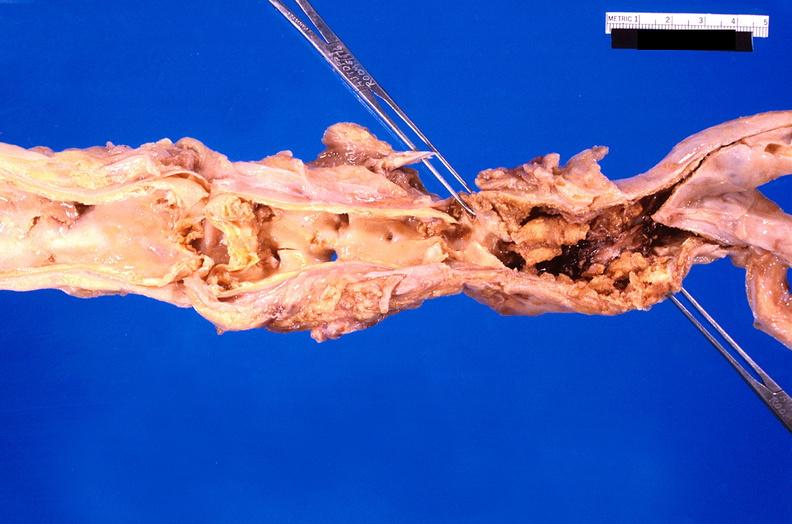what is present?
Answer the question using a single word or phrase. Cardiovascular 